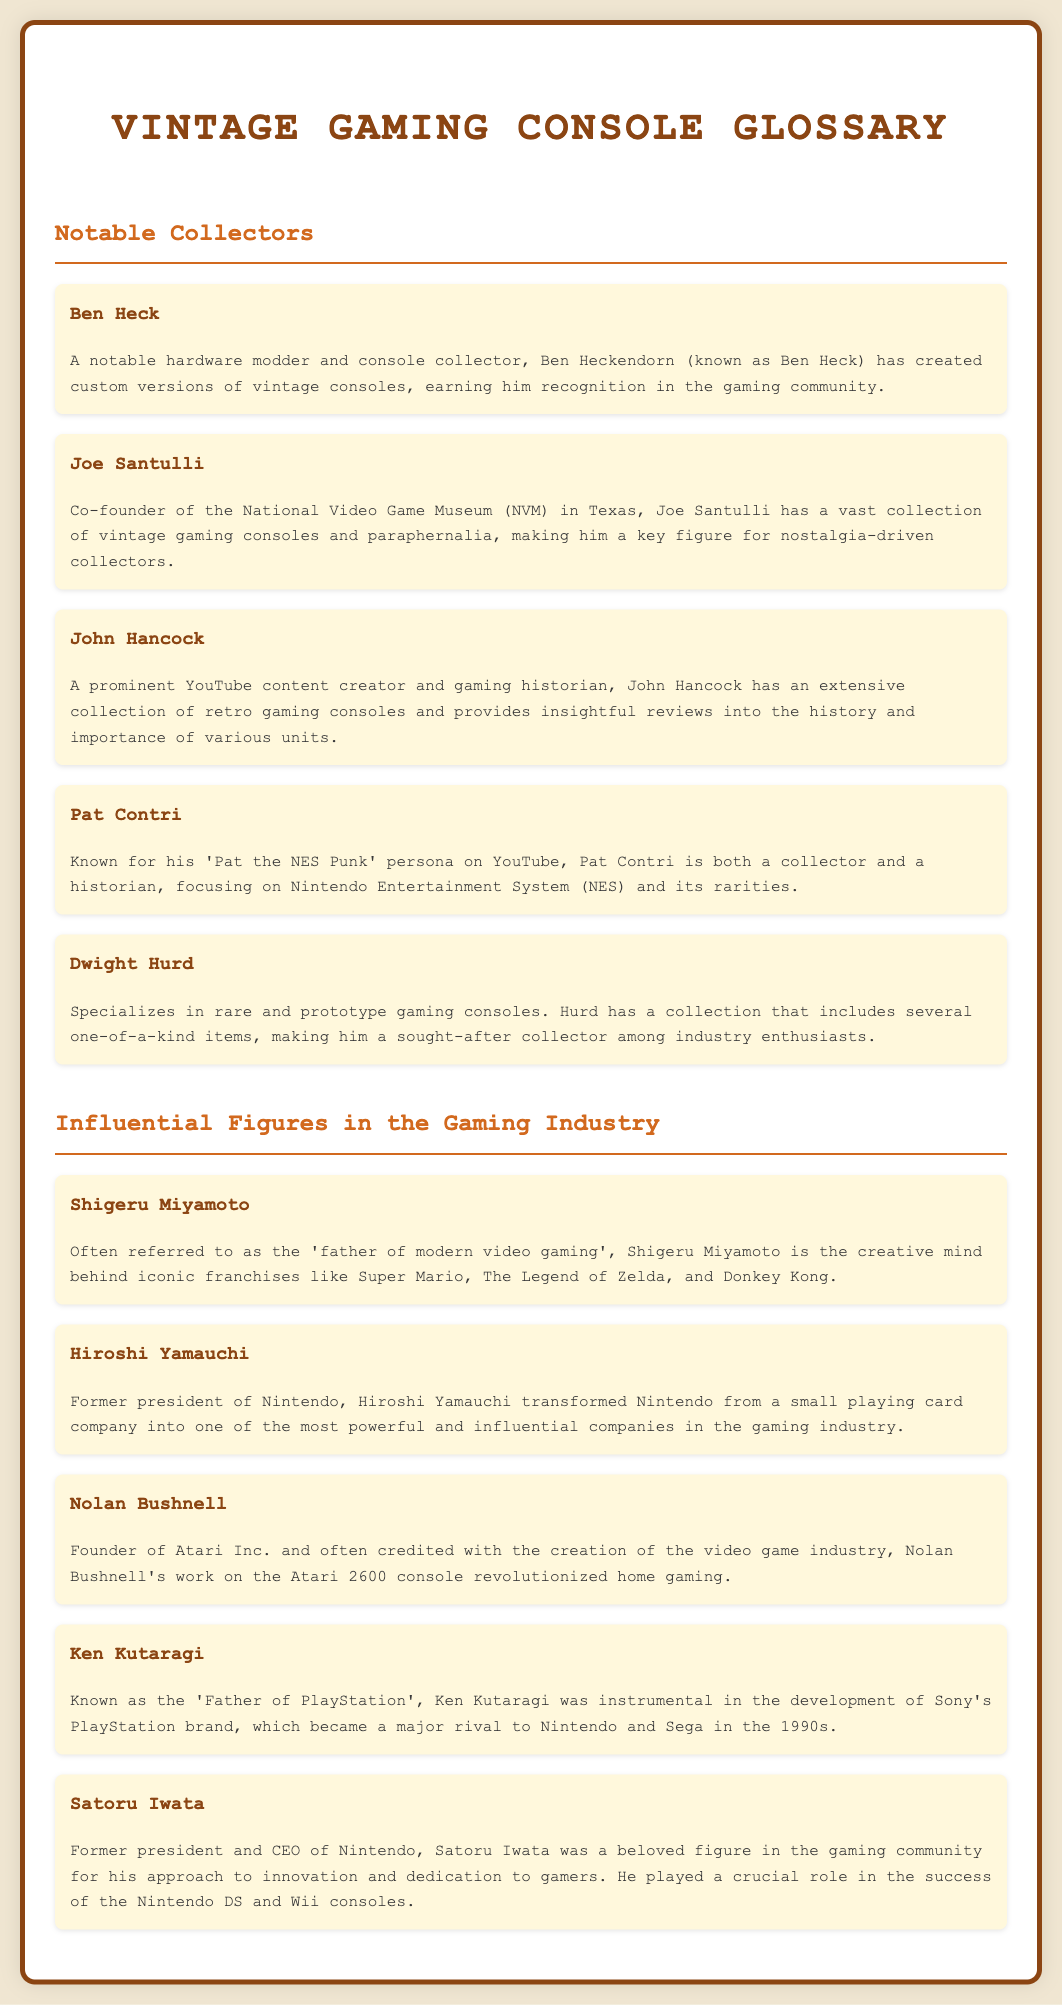What is the profession of Ben Heck? Ben Heck is described as a notable hardware modder and console collector, highlighting his role in the gaming community.
Answer: hardware modder and console collector Who co-founded the National Video Game Museum? Joe Santulli is noted in the document as the co-founder of the National Video Game Museum (NVM) in Texas.
Answer: Joe Santulli Which YouTube persona is associated with Pat Contri? Pat Contri operates under the 'Pat the NES Punk' persona on YouTube, as mentioned in the glossary.
Answer: Pat the NES Punk What game franchise did Shigeru Miyamoto develop? The glossary mentions Shigeru Miyamoto is the creative mind behind iconic franchises, including Super Mario.
Answer: Super Mario Which console is Nolan Bushnell credited with creating? Nolan Bushnell is credited with the creation of the video game industry and the Atari 2600 console, as per the document.
Answer: Atari 2600 Who is known as the ‘Father of PlayStation’? Ken Kutaragi is explicitly referred to as the 'Father of PlayStation' in the glossary.
Answer: Ken Kutaragi What is Dwight Hurd's specialization? The document states that Dwight Hurd specializes in rare and prototype gaming consoles.
Answer: rare and prototype gaming consoles Which company did Hiroshi Yamauchi lead? The document informs that Hiroshi Yamauchi was the former president of Nintendo, indicating the company he led.
Answer: Nintendo Who played a crucial role in the success of the Nintendo DS? Satoru Iwata is mentioned as having played a crucial role in the success of the Nintendo DS and Wii consoles.
Answer: Satoru Iwata 